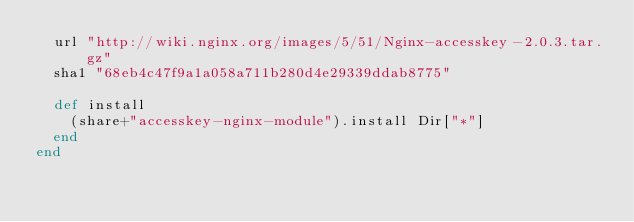<code> <loc_0><loc_0><loc_500><loc_500><_Ruby_>  url "http://wiki.nginx.org/images/5/51/Nginx-accesskey-2.0.3.tar.gz"
  sha1 "68eb4c47f9a1a058a711b280d4e29339ddab8775"

  def install
    (share+"accesskey-nginx-module").install Dir["*"]
  end
end
</code> 